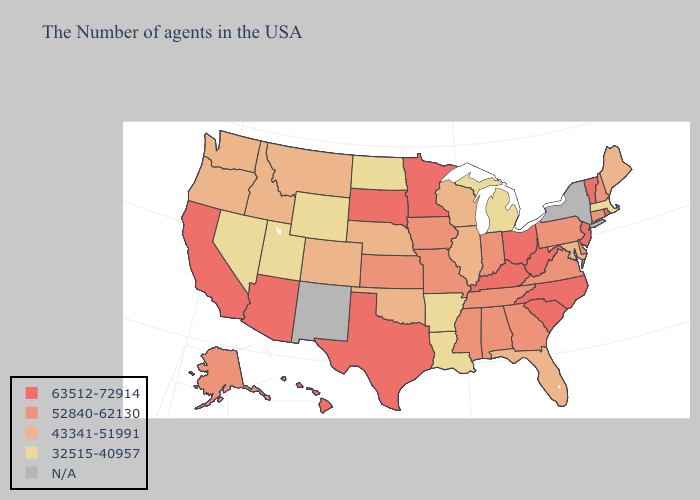Among the states that border Tennessee , does Kentucky have the highest value?
Be succinct. Yes. Does New Hampshire have the highest value in the USA?
Keep it brief. No. Name the states that have a value in the range N/A?
Write a very short answer. New York, New Mexico. What is the value of New York?
Write a very short answer. N/A. What is the lowest value in the Northeast?
Short answer required. 32515-40957. Which states have the highest value in the USA?
Be succinct. Rhode Island, Vermont, New Jersey, North Carolina, South Carolina, West Virginia, Ohio, Kentucky, Minnesota, Texas, South Dakota, Arizona, California, Hawaii. Name the states that have a value in the range 43341-51991?
Quick response, please. Maine, Maryland, Florida, Wisconsin, Illinois, Nebraska, Oklahoma, Colorado, Montana, Idaho, Washington, Oregon. What is the value of Florida?
Give a very brief answer. 43341-51991. Name the states that have a value in the range 63512-72914?
Answer briefly. Rhode Island, Vermont, New Jersey, North Carolina, South Carolina, West Virginia, Ohio, Kentucky, Minnesota, Texas, South Dakota, Arizona, California, Hawaii. Does Idaho have the lowest value in the USA?
Keep it brief. No. Does North Dakota have the lowest value in the USA?
Give a very brief answer. Yes. What is the highest value in the Northeast ?
Write a very short answer. 63512-72914. What is the highest value in the USA?
Short answer required. 63512-72914. What is the lowest value in states that border New Hampshire?
Quick response, please. 32515-40957. Name the states that have a value in the range 52840-62130?
Write a very short answer. New Hampshire, Connecticut, Delaware, Pennsylvania, Virginia, Georgia, Indiana, Alabama, Tennessee, Mississippi, Missouri, Iowa, Kansas, Alaska. 